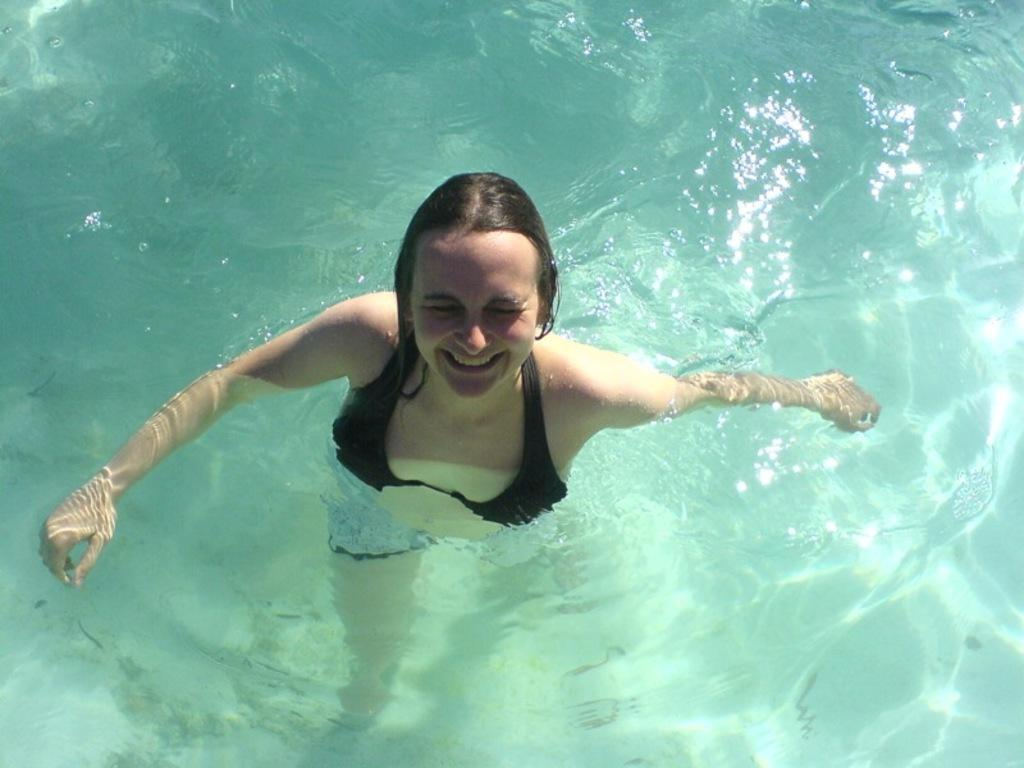Who is the main subject in the foreground of the image? There is a woman in the foreground of the image. What is the woman's location in relation to the image? The woman is in the water. What type of unit is the woman using to measure the water's depth in the image? There is no unit visible in the image, and the woman's purpose in the water is not specified. 